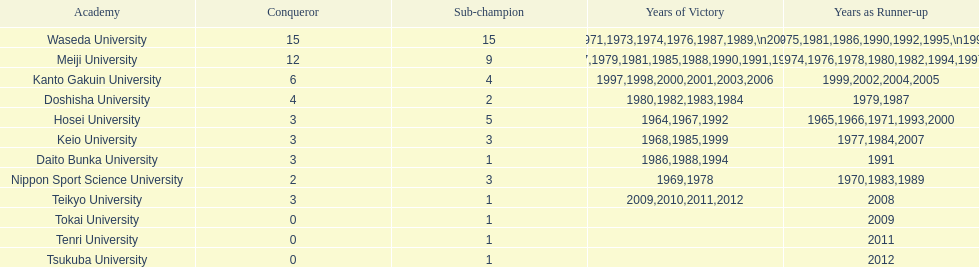Which university secured the most victories over the years? Waseda University. 